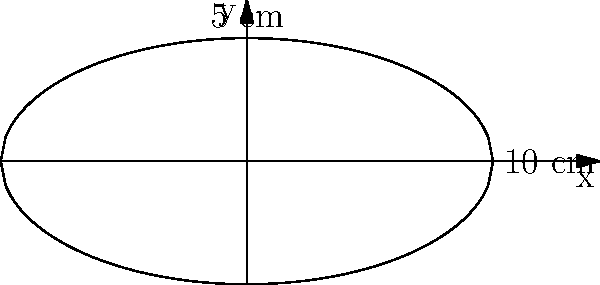During an excavation, you discover an ancient pottery vessel resembling a spheroid. The cross-section of the vessel can be represented by the equation $\frac{x^2}{a^2} + \frac{y^2}{b^2} = 1$, where $a = 10$ cm and $b = 5$ cm. Calculate the volume of this vessel, assuming it's formed by rotating the cross-section around the x-axis. To calculate the volume of the vessel, we'll use the formula for the volume of a solid of revolution:

1) The volume formula is: $V = \pi \int_{-a}^{a} [f(x)]^2 dx$

2) In this case, $f(x) = b\sqrt{1-\frac{x^2}{a^2}}$

3) Substituting the values:
   $V = \pi \int_{-10}^{10} [5\sqrt{1-\frac{x^2}{100}}]^2 dx$

4) Simplify:
   $V = 25\pi \int_{-10}^{10} (1-\frac{x^2}{100}) dx$

5) Integrate:
   $V = 25\pi [x - \frac{x^3}{300}]_{-10}^{10}$

6) Evaluate:
   $V = 25\pi [(10 - \frac{1000}{300}) - (-10 - \frac{-1000}{300})]$
   $V = 25\pi [(\frac{10}{3}) - (-\frac{10}{3})]$
   $V = 25\pi [\frac{20}{3}]$

7) Simplify:
   $V = \frac{500\pi}{3}$ cubic centimeters
Answer: $\frac{500\pi}{3}$ cm³ 